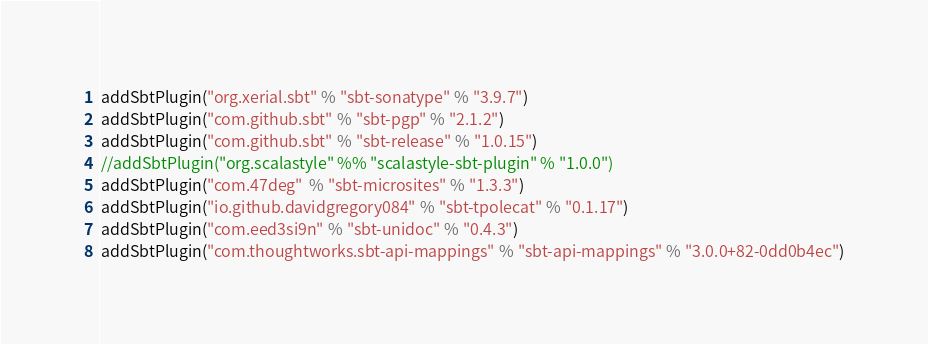<code> <loc_0><loc_0><loc_500><loc_500><_Scala_>addSbtPlugin("org.xerial.sbt" % "sbt-sonatype" % "3.9.7")
addSbtPlugin("com.github.sbt" % "sbt-pgp" % "2.1.2")
addSbtPlugin("com.github.sbt" % "sbt-release" % "1.0.15")
//addSbtPlugin("org.scalastyle" %% "scalastyle-sbt-plugin" % "1.0.0")
addSbtPlugin("com.47deg"  % "sbt-microsites" % "1.3.3")
addSbtPlugin("io.github.davidgregory084" % "sbt-tpolecat" % "0.1.17")
addSbtPlugin("com.eed3si9n" % "sbt-unidoc" % "0.4.3")
addSbtPlugin("com.thoughtworks.sbt-api-mappings" % "sbt-api-mappings" % "3.0.0+82-0dd0b4ec")</code> 